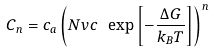<formula> <loc_0><loc_0><loc_500><loc_500>C _ { n } = c _ { a } \left ( N v c \ \exp \left [ - \frac { \Delta G } { k _ { B } T } \right ] \right ) ^ { n }</formula> 